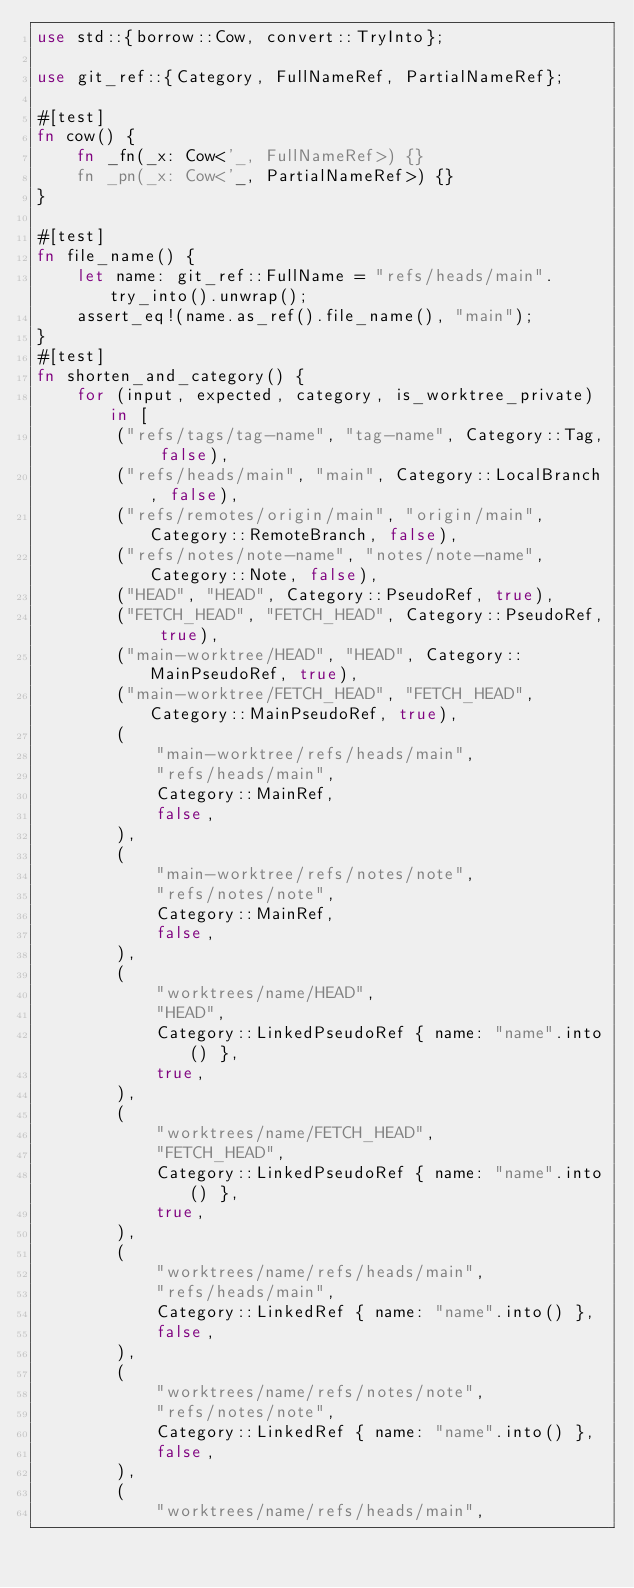<code> <loc_0><loc_0><loc_500><loc_500><_Rust_>use std::{borrow::Cow, convert::TryInto};

use git_ref::{Category, FullNameRef, PartialNameRef};

#[test]
fn cow() {
    fn _fn(_x: Cow<'_, FullNameRef>) {}
    fn _pn(_x: Cow<'_, PartialNameRef>) {}
}

#[test]
fn file_name() {
    let name: git_ref::FullName = "refs/heads/main".try_into().unwrap();
    assert_eq!(name.as_ref().file_name(), "main");
}
#[test]
fn shorten_and_category() {
    for (input, expected, category, is_worktree_private) in [
        ("refs/tags/tag-name", "tag-name", Category::Tag, false),
        ("refs/heads/main", "main", Category::LocalBranch, false),
        ("refs/remotes/origin/main", "origin/main", Category::RemoteBranch, false),
        ("refs/notes/note-name", "notes/note-name", Category::Note, false),
        ("HEAD", "HEAD", Category::PseudoRef, true),
        ("FETCH_HEAD", "FETCH_HEAD", Category::PseudoRef, true),
        ("main-worktree/HEAD", "HEAD", Category::MainPseudoRef, true),
        ("main-worktree/FETCH_HEAD", "FETCH_HEAD", Category::MainPseudoRef, true),
        (
            "main-worktree/refs/heads/main",
            "refs/heads/main",
            Category::MainRef,
            false,
        ),
        (
            "main-worktree/refs/notes/note",
            "refs/notes/note",
            Category::MainRef,
            false,
        ),
        (
            "worktrees/name/HEAD",
            "HEAD",
            Category::LinkedPseudoRef { name: "name".into() },
            true,
        ),
        (
            "worktrees/name/FETCH_HEAD",
            "FETCH_HEAD",
            Category::LinkedPseudoRef { name: "name".into() },
            true,
        ),
        (
            "worktrees/name/refs/heads/main",
            "refs/heads/main",
            Category::LinkedRef { name: "name".into() },
            false,
        ),
        (
            "worktrees/name/refs/notes/note",
            "refs/notes/note",
            Category::LinkedRef { name: "name".into() },
            false,
        ),
        (
            "worktrees/name/refs/heads/main",</code> 